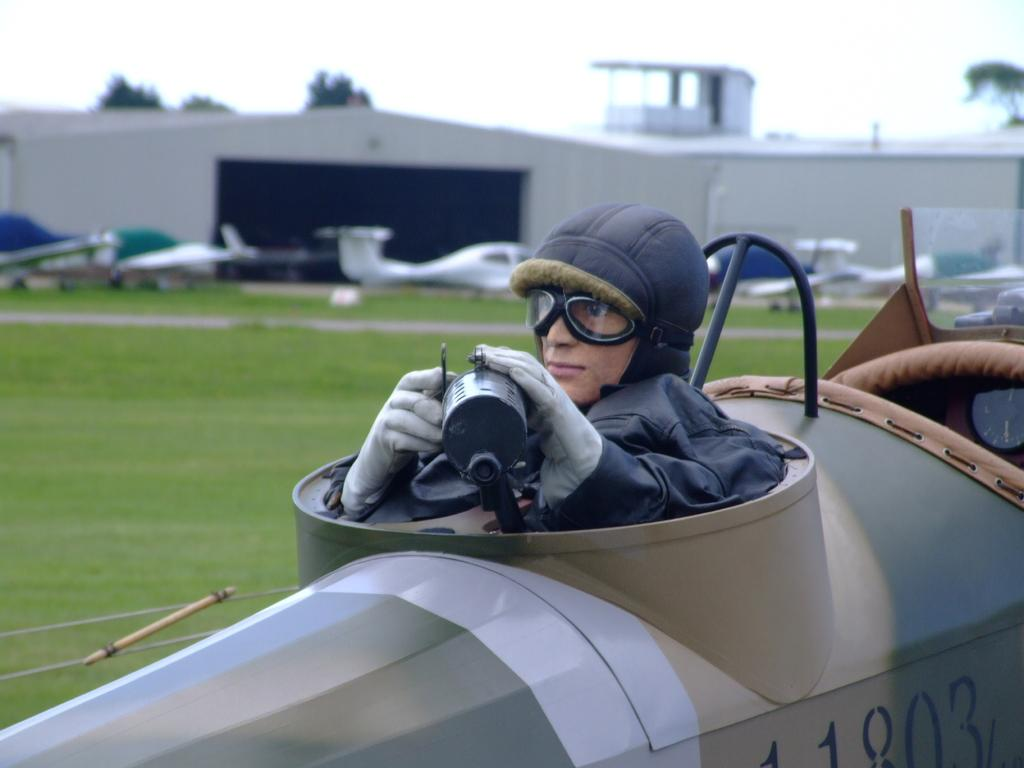What is the main subject of the image? The main subject of the image is planes. Can you describe the person in the image? The person in the image is wearing goggles and holding an object. What type of structure can be seen in the image? There is a shed in the image. What natural elements are present in the image? There is a tree, grass, and sky visible in the image. How would you describe the background of the image? The background of the image is blurry. What type of joke is the person telling in the image? There is no indication of a joke being told in the image; the person is simply wearing goggles and holding an object. Can you describe the truck that is parked next to the shed in the image? There is no truck present in the image; only planes, a person, a shed, a tree, grass, sky, and a blurry background are visible. 